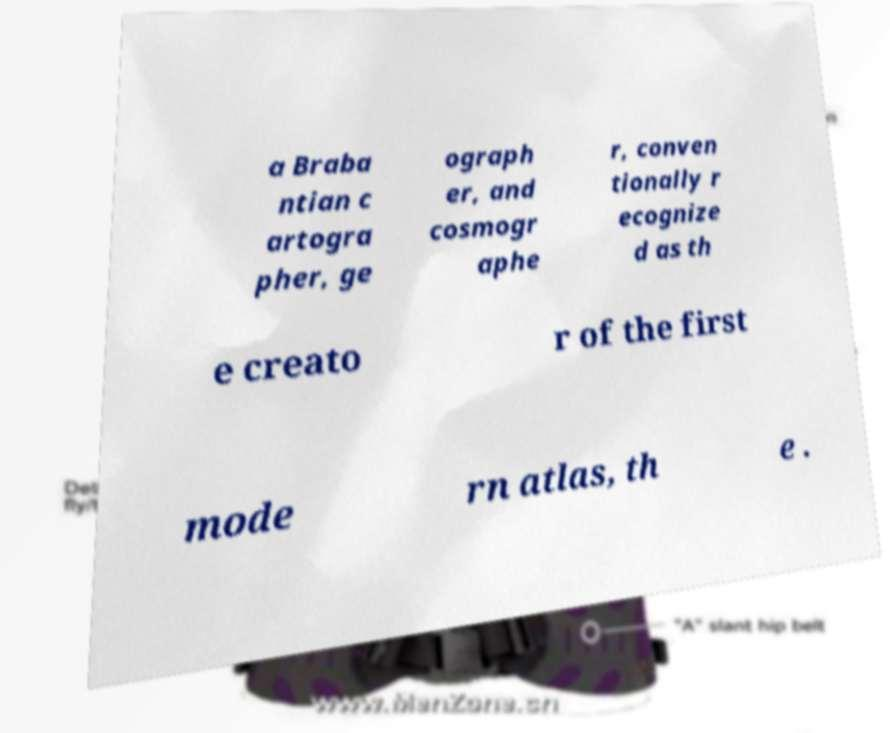I need the written content from this picture converted into text. Can you do that? a Braba ntian c artogra pher, ge ograph er, and cosmogr aphe r, conven tionally r ecognize d as th e creato r of the first mode rn atlas, th e . 